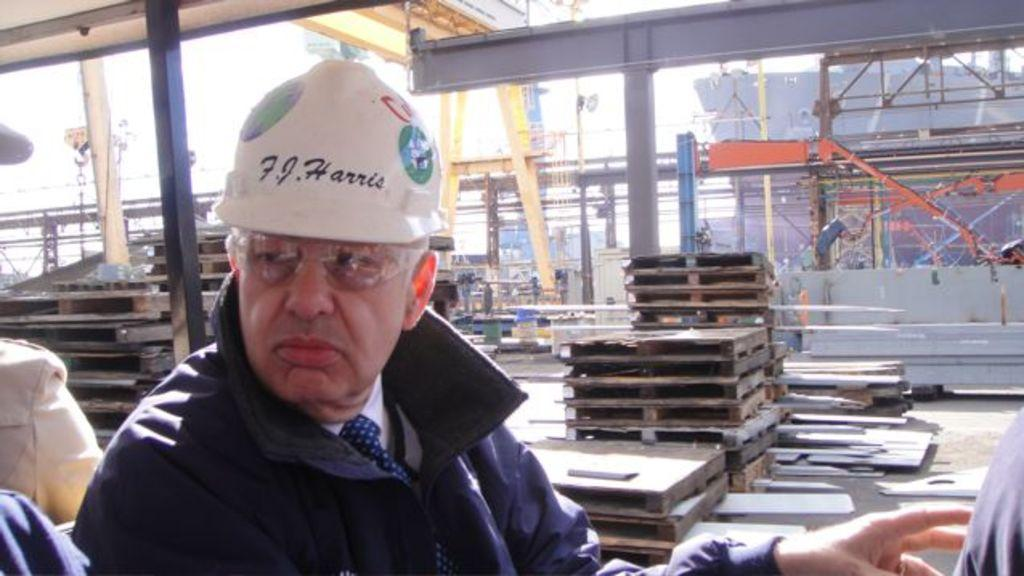Who is present in the image? There is a man in the image. What is the man wearing on his head? The man is wearing a helmet. What can be seen in the background of the image? There is construction material, cranes, a ship, and the sky visible in the background of the image. What type of soap is the man using to clean the doll in the image? There is no soap, doll, or cleaning activity present in the image. 